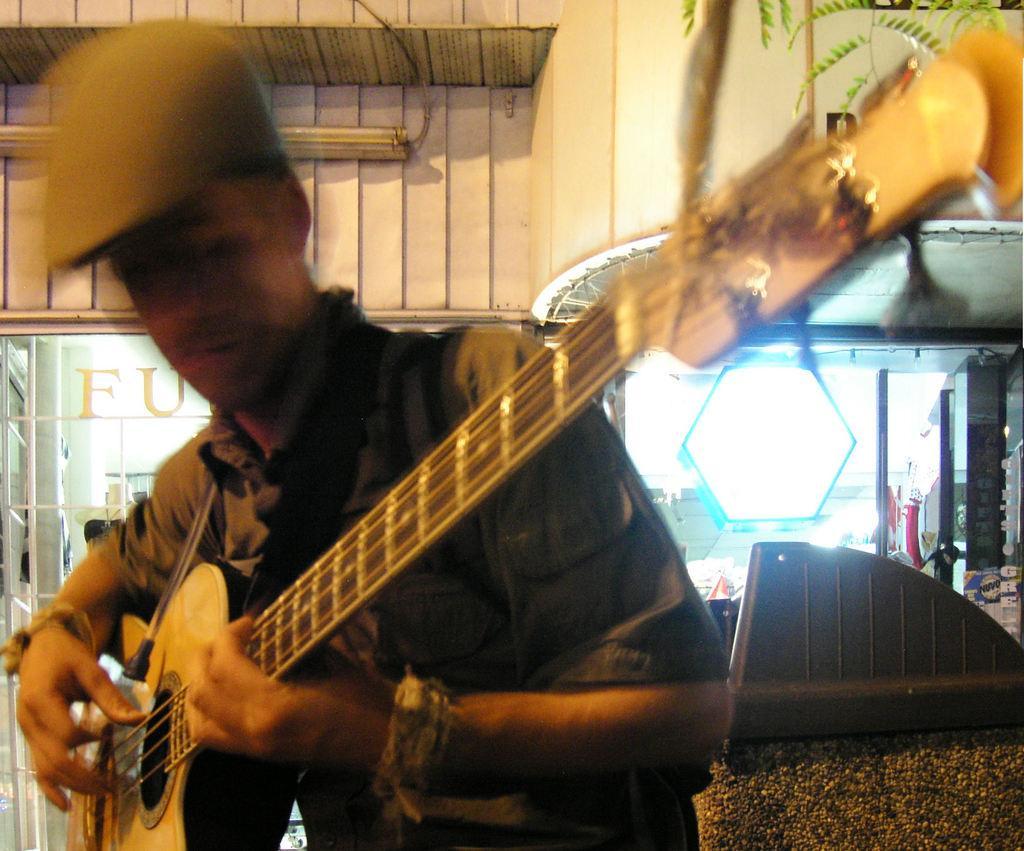How would you summarize this image in a sentence or two? As we can see in the image there is a man holding guitar. 